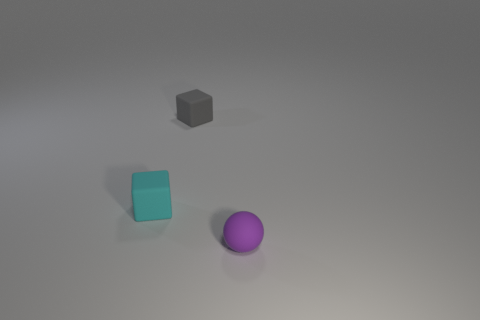Are there fewer cyan cubes that are behind the gray block than matte spheres? As observed in the image, there is only one cyan cube and it is not behind the gray block but rather to the side, and there is only one matte sphere. So, to accurately answer your question, there are not fewer cyan cubes behind the gray block than matte spheres since there are no cubes behind the block at all. 